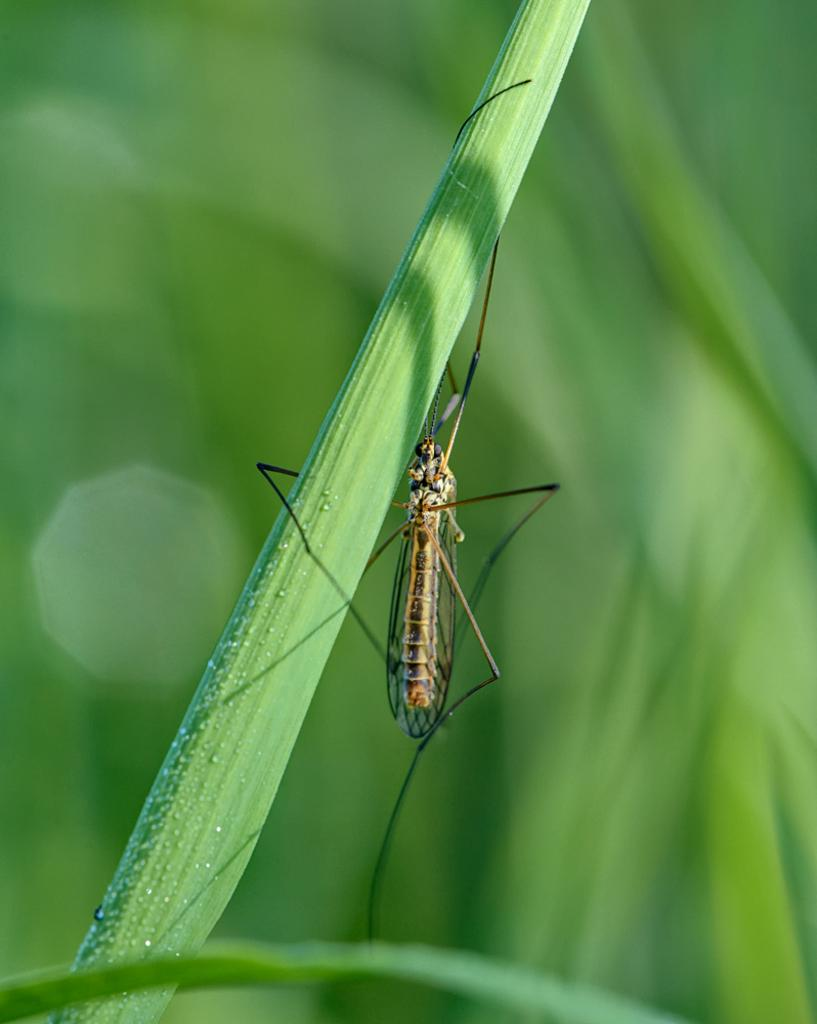What is the main subject of the image? The main subject of the image is a mosquito. Where is the mosquito located in the image? The mosquito is on a leaf in the image. Can you describe the position of the mosquito and leaf in the image? The mosquito and leaf are in the center of the image. What type of cord is being used to shock the mosquito in the image? There is no cord or shocking device present in the image; it only features a mosquito on a leaf. 